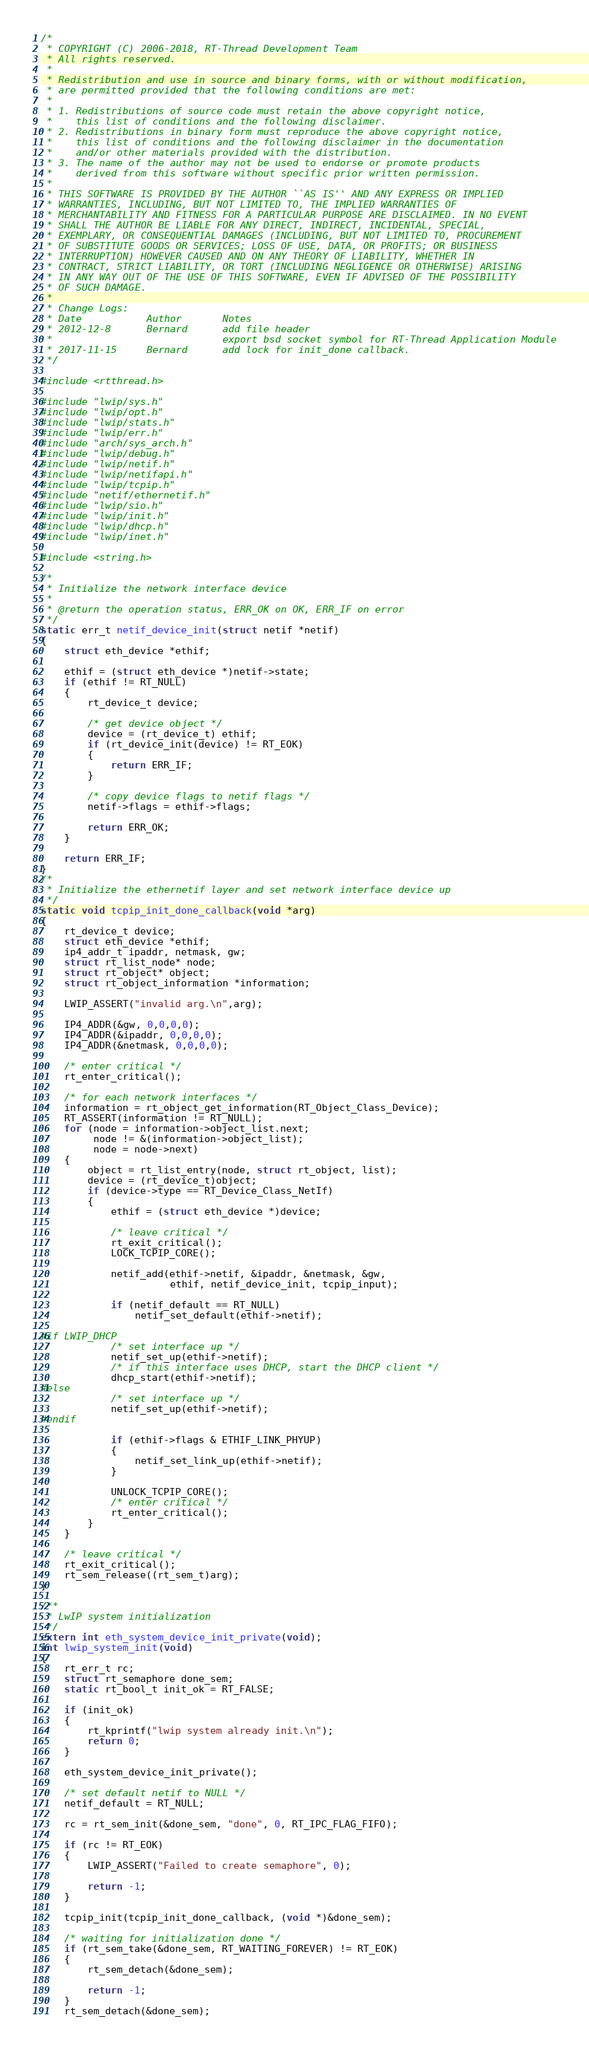Convert code to text. <code><loc_0><loc_0><loc_500><loc_500><_C_>/*
 * COPYRIGHT (C) 2006-2018, RT-Thread Development Team
 * All rights reserved.
 *
 * Redistribution and use in source and binary forms, with or without modification,
 * are permitted provided that the following conditions are met:
 *
 * 1. Redistributions of source code must retain the above copyright notice,
 *    this list of conditions and the following disclaimer.
 * 2. Redistributions in binary form must reproduce the above copyright notice,
 *    this list of conditions and the following disclaimer in the documentation
 *    and/or other materials provided with the distribution.
 * 3. The name of the author may not be used to endorse or promote products
 *    derived from this software without specific prior written permission.
 *
 * THIS SOFTWARE IS PROVIDED BY THE AUTHOR ``AS IS'' AND ANY EXPRESS OR IMPLIED
 * WARRANTIES, INCLUDING, BUT NOT LIMITED TO, THE IMPLIED WARRANTIES OF
 * MERCHANTABILITY AND FITNESS FOR A PARTICULAR PURPOSE ARE DISCLAIMED. IN NO EVENT
 * SHALL THE AUTHOR BE LIABLE FOR ANY DIRECT, INDIRECT, INCIDENTAL, SPECIAL,
 * EXEMPLARY, OR CONSEQUENTIAL DAMAGES (INCLUDING, BUT NOT LIMITED TO, PROCUREMENT
 * OF SUBSTITUTE GOODS OR SERVICES; LOSS OF USE, DATA, OR PROFITS; OR BUSINESS
 * INTERRUPTION) HOWEVER CAUSED AND ON ANY THEORY OF LIABILITY, WHETHER IN
 * CONTRACT, STRICT LIABILITY, OR TORT (INCLUDING NEGLIGENCE OR OTHERWISE) ARISING
 * IN ANY WAY OUT OF THE USE OF THIS SOFTWARE, EVEN IF ADVISED OF THE POSSIBILITY
 * OF SUCH DAMAGE.
 *
 * Change Logs:
 * Date           Author       Notes
 * 2012-12-8      Bernard      add file header
 *                             export bsd socket symbol for RT-Thread Application Module
 * 2017-11-15     Bernard      add lock for init_done callback.
 */

#include <rtthread.h>

#include "lwip/sys.h"
#include "lwip/opt.h"
#include "lwip/stats.h"
#include "lwip/err.h"
#include "arch/sys_arch.h"
#include "lwip/debug.h"
#include "lwip/netif.h"
#include "lwip/netifapi.h"
#include "lwip/tcpip.h"
#include "netif/ethernetif.h"
#include "lwip/sio.h"
#include "lwip/init.h"
#include "lwip/dhcp.h"
#include "lwip/inet.h"

#include <string.h>

/*
 * Initialize the network interface device
 *
 * @return the operation status, ERR_OK on OK, ERR_IF on error
 */
static err_t netif_device_init(struct netif *netif)
{
    struct eth_device *ethif;

    ethif = (struct eth_device *)netif->state;
    if (ethif != RT_NULL)
    {
        rt_device_t device;

        /* get device object */
        device = (rt_device_t) ethif;
        if (rt_device_init(device) != RT_EOK)
        {
            return ERR_IF;
        }

        /* copy device flags to netif flags */
        netif->flags = ethif->flags;

        return ERR_OK;
    }

    return ERR_IF;
}
/*
 * Initialize the ethernetif layer and set network interface device up
 */
static void tcpip_init_done_callback(void *arg)
{
    rt_device_t device;
    struct eth_device *ethif;
    ip4_addr_t ipaddr, netmask, gw;
    struct rt_list_node* node;
    struct rt_object* object;
    struct rt_object_information *information;

    LWIP_ASSERT("invalid arg.\n",arg);

    IP4_ADDR(&gw, 0,0,0,0);
    IP4_ADDR(&ipaddr, 0,0,0,0);
    IP4_ADDR(&netmask, 0,0,0,0);

    /* enter critical */
    rt_enter_critical();

    /* for each network interfaces */
    information = rt_object_get_information(RT_Object_Class_Device);
    RT_ASSERT(information != RT_NULL);
    for (node = information->object_list.next;
         node != &(information->object_list);
         node = node->next)
    {
        object = rt_list_entry(node, struct rt_object, list);
        device = (rt_device_t)object;
        if (device->type == RT_Device_Class_NetIf)
        {
            ethif = (struct eth_device *)device;

            /* leave critical */
            rt_exit_critical();
            LOCK_TCPIP_CORE();

            netif_add(ethif->netif, &ipaddr, &netmask, &gw,
                      ethif, netif_device_init, tcpip_input);

            if (netif_default == RT_NULL)
                netif_set_default(ethif->netif);

#if LWIP_DHCP
            /* set interface up */
            netif_set_up(ethif->netif);
            /* if this interface uses DHCP, start the DHCP client */
            dhcp_start(ethif->netif);
#else
            /* set interface up */
            netif_set_up(ethif->netif);
#endif

            if (ethif->flags & ETHIF_LINK_PHYUP)
            {
                netif_set_link_up(ethif->netif);
            }

            UNLOCK_TCPIP_CORE();
            /* enter critical */
            rt_enter_critical();
        }
    }

    /* leave critical */
    rt_exit_critical();
    rt_sem_release((rt_sem_t)arg);
}

/**
 * LwIP system initialization
 */
extern int eth_system_device_init_private(void);
int lwip_system_init(void)
{
    rt_err_t rc;
    struct rt_semaphore done_sem;
    static rt_bool_t init_ok = RT_FALSE;

    if (init_ok)
    {
        rt_kprintf("lwip system already init.\n");
        return 0;
    }

    eth_system_device_init_private();

    /* set default netif to NULL */
    netif_default = RT_NULL;

    rc = rt_sem_init(&done_sem, "done", 0, RT_IPC_FLAG_FIFO);

    if (rc != RT_EOK)
    {
        LWIP_ASSERT("Failed to create semaphore", 0);

        return -1;
    }

    tcpip_init(tcpip_init_done_callback, (void *)&done_sem);

    /* waiting for initialization done */
    if (rt_sem_take(&done_sem, RT_WAITING_FOREVER) != RT_EOK)
    {
        rt_sem_detach(&done_sem);

        return -1;
    }
    rt_sem_detach(&done_sem);
</code> 